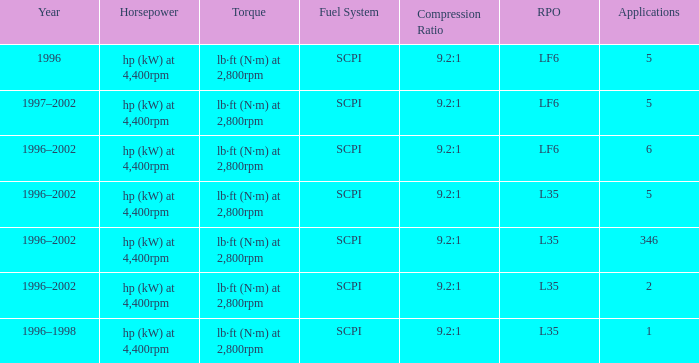What are the torque features of the 1996 model? Lb·ft (n·m) at 2,800rpm. 